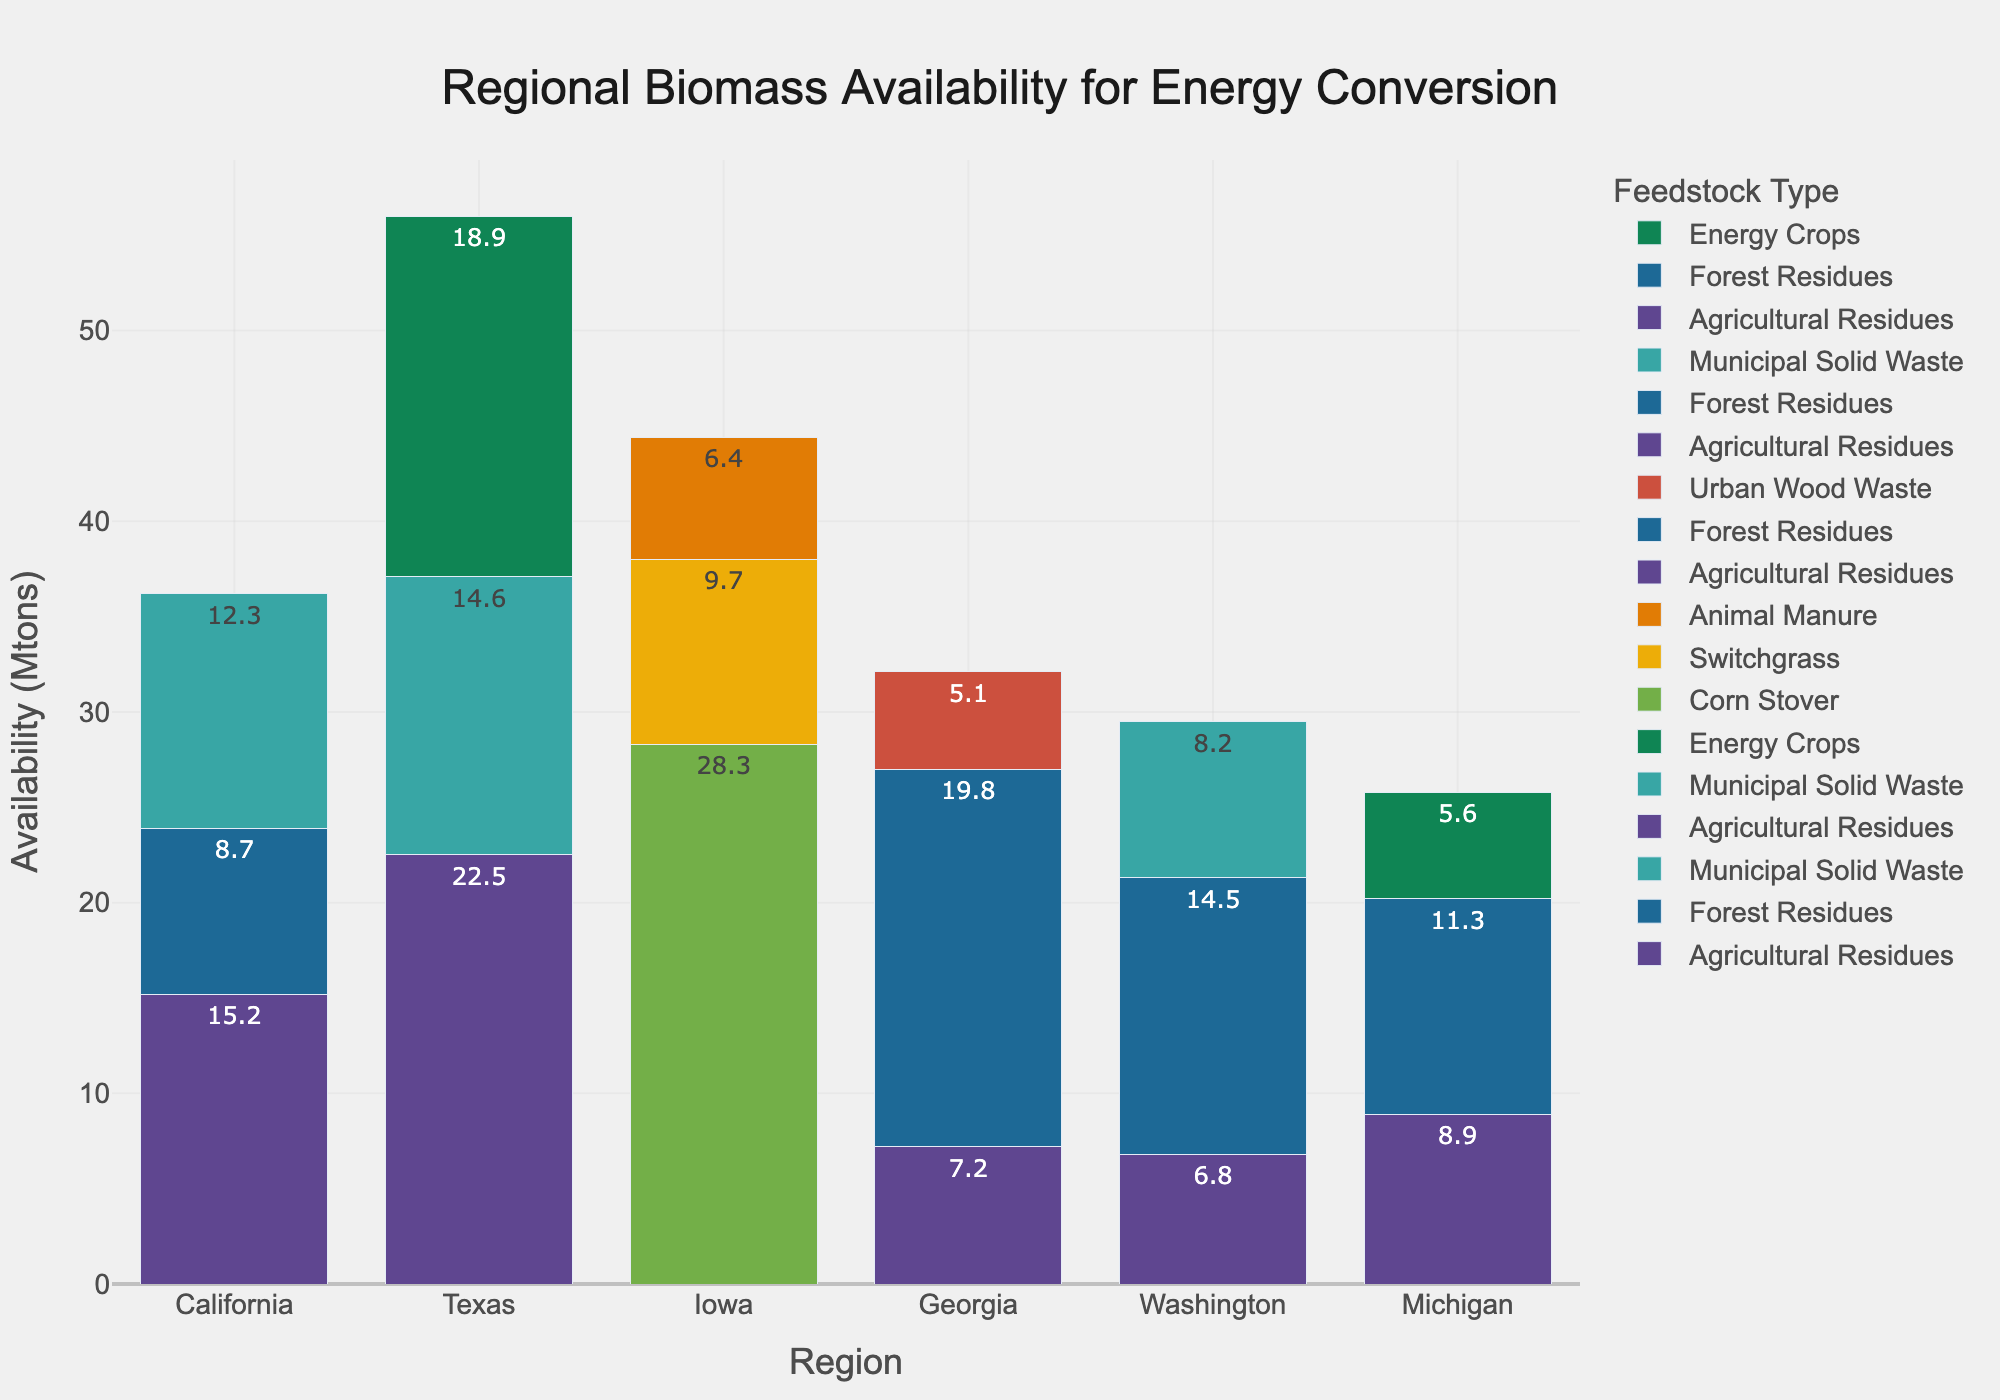Which region has the highest total biomass availability? Summing up the biomass availabilities in each region, we get:
- California: 15.2 + 8.7 + 12.3 = 36.2 Mtons
- Texas: 22.5 + 18.9 + 14.6 = 56.0 Mtons
- Iowa: 28.3 + 9.7 + 6.4 = 44.4 Mtons
- Georgia: 19.8 + 7.2 + 5.1 = 32.1 Mtons
- Washington: 14.5 + 6.8 + 8.2 = 29.5 Mtons
- Michigan: 11.3 + 8.9 + 5.6 = 25.8 Mtons
Texas has the highest total biomass availability at 56.0 Mtons.
Answer: Texas Which feedstock type has the highest availability in Iowa? Checking the feedstocks in Iowa:
- Corn Stover: 28.3 Mtons
- Switchgrass: 9.7 Mtons
- Animal Manure: 6.4 Mtons
Corn Stover has the highest availability at 28.3 Mtons.
Answer: Corn Stover How does the availability of Agricultural Residues in California compare to that in Texas? Agricultural Residues in:
- California: 15.2 Mtons
- Texas: 22.5 Mtons
Texas has more availability of Agricultural Residues than California.
Answer: Texas has more What's the total availability of Forest Residues across all regions? Summing up the Forest Residues across all regions:
- California: 8.7 Mtons
- Georgia: 19.8 Mtons
- Washington: 14.5 Mtons
- Michigan: 11.3 Mtons
Total = 8.7 + 19.8 + 14.5 + 11.3 = 54.3 Mtons
Answer: 54.3 Mtons Which region has the lowest biomass availability for Energy Crops? Checking the regions with Energy Crops:
- Texas: 18.9 Mtons
- Michigan: 5.6 Mtons
Michigan has the lowest availability for Energy Crops at 5.6 Mtons.
Answer: Michigan Which feedstock type is only found in Washington among the listed regions? Checking the feedstock types in Washington:
- Agricultural Residues, Forest Residues, Municipal Solid Waste are present in other regions
None of the feedstock types are unique to Washington.
Answer: None What is the combined biomass availability for Municipal Solid Waste in California and Texas? Adding Municipal Solid Waste in:
- California: 12.3 Mtons
- Texas: 14.6 Mtons
Combined = 12.3 + 14.6 = 26.9 Mtons
Answer: 26.9 Mtons 